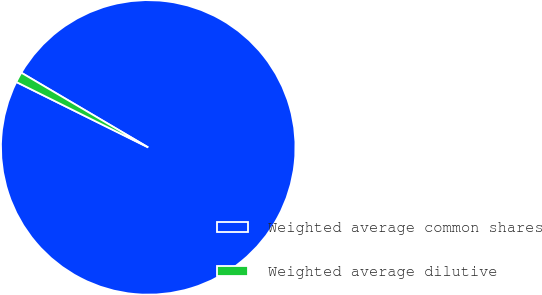Convert chart. <chart><loc_0><loc_0><loc_500><loc_500><pie_chart><fcel>Weighted average common shares<fcel>Weighted average dilutive<nl><fcel>98.86%<fcel>1.14%<nl></chart> 